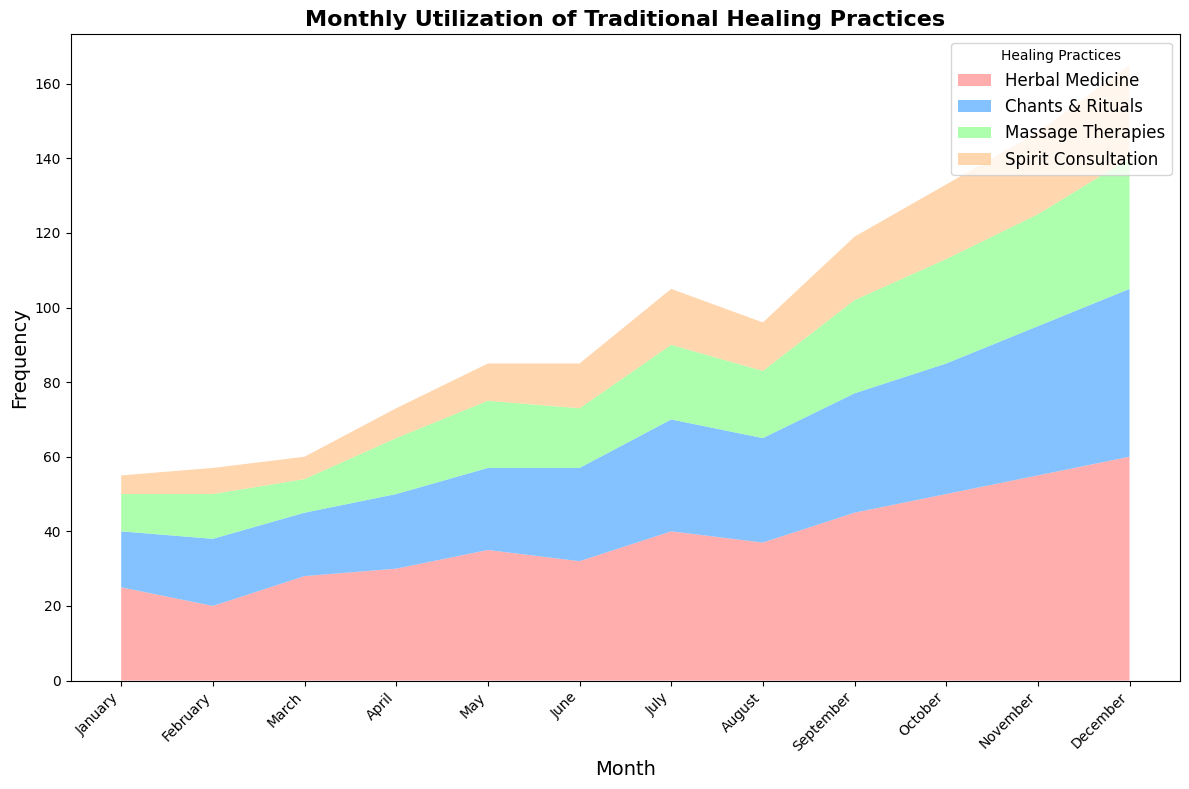Which type of healing practice is the most utilized in January? By looking at the figure, the highest area plot segment for January is red. From the legend, red represents Herbal Medicine.
Answer: Herbal Medicine How many more times is Herbal Medicine used compared to Spirit Consultation in July? Observing the figure, Herbal Medicine is around 40 in July, and Spirit Consultation is around 15. The difference is 40 - 15 = 25.
Answer: 25 Which month had the highest total frequency for all healing practices? By comparing the heights of the areas stacked at the top of each month, December has the highest combined frequency.
Answer: December What is the combined frequency of Chants & Rituals and Massage Therapies in April? From the figure, Chants & Rituals is around 20 in April, and Massage Therapies is around 15. The combined frequency is 20 + 15 = 35.
Answer: 35 Which month had the greatest increase in Herbal Medicine usage from the previous month? Observing the red segments, from September to October, Herbal Medicine increased from about 45 to 50, which is a 5-unit increase. This is the biggest increment visually.
Answer: October Is there any month where Chants & Rituals surpass Massage Therapies by at least 15? From the figure, in December, Chants & Rituals are around 45, and Massage Therapies are around 35. The difference is 45 - 35 = 10, which doesn't meet the condition. No month satisfies this requirement.
Answer: No During which month was Spirit Consultation frequency half of Herbal Medicine? In October, Herbal Medicine is at 50 and Spirit Consultation is at 20 which is half of Herbal Medicine's value.
Answer: October What is the frequency of Massage Therapies in August? Observing the green segment, Massage Therapies in August is around 18.
Answer: 18 Which healing practice has the smallest change in frequency from January to December? Spirit Consultation starts at 5 in January and ends at 25 in December. Comparing the changes, it has the smallest visual change.
Answer: Spirit Consultation 